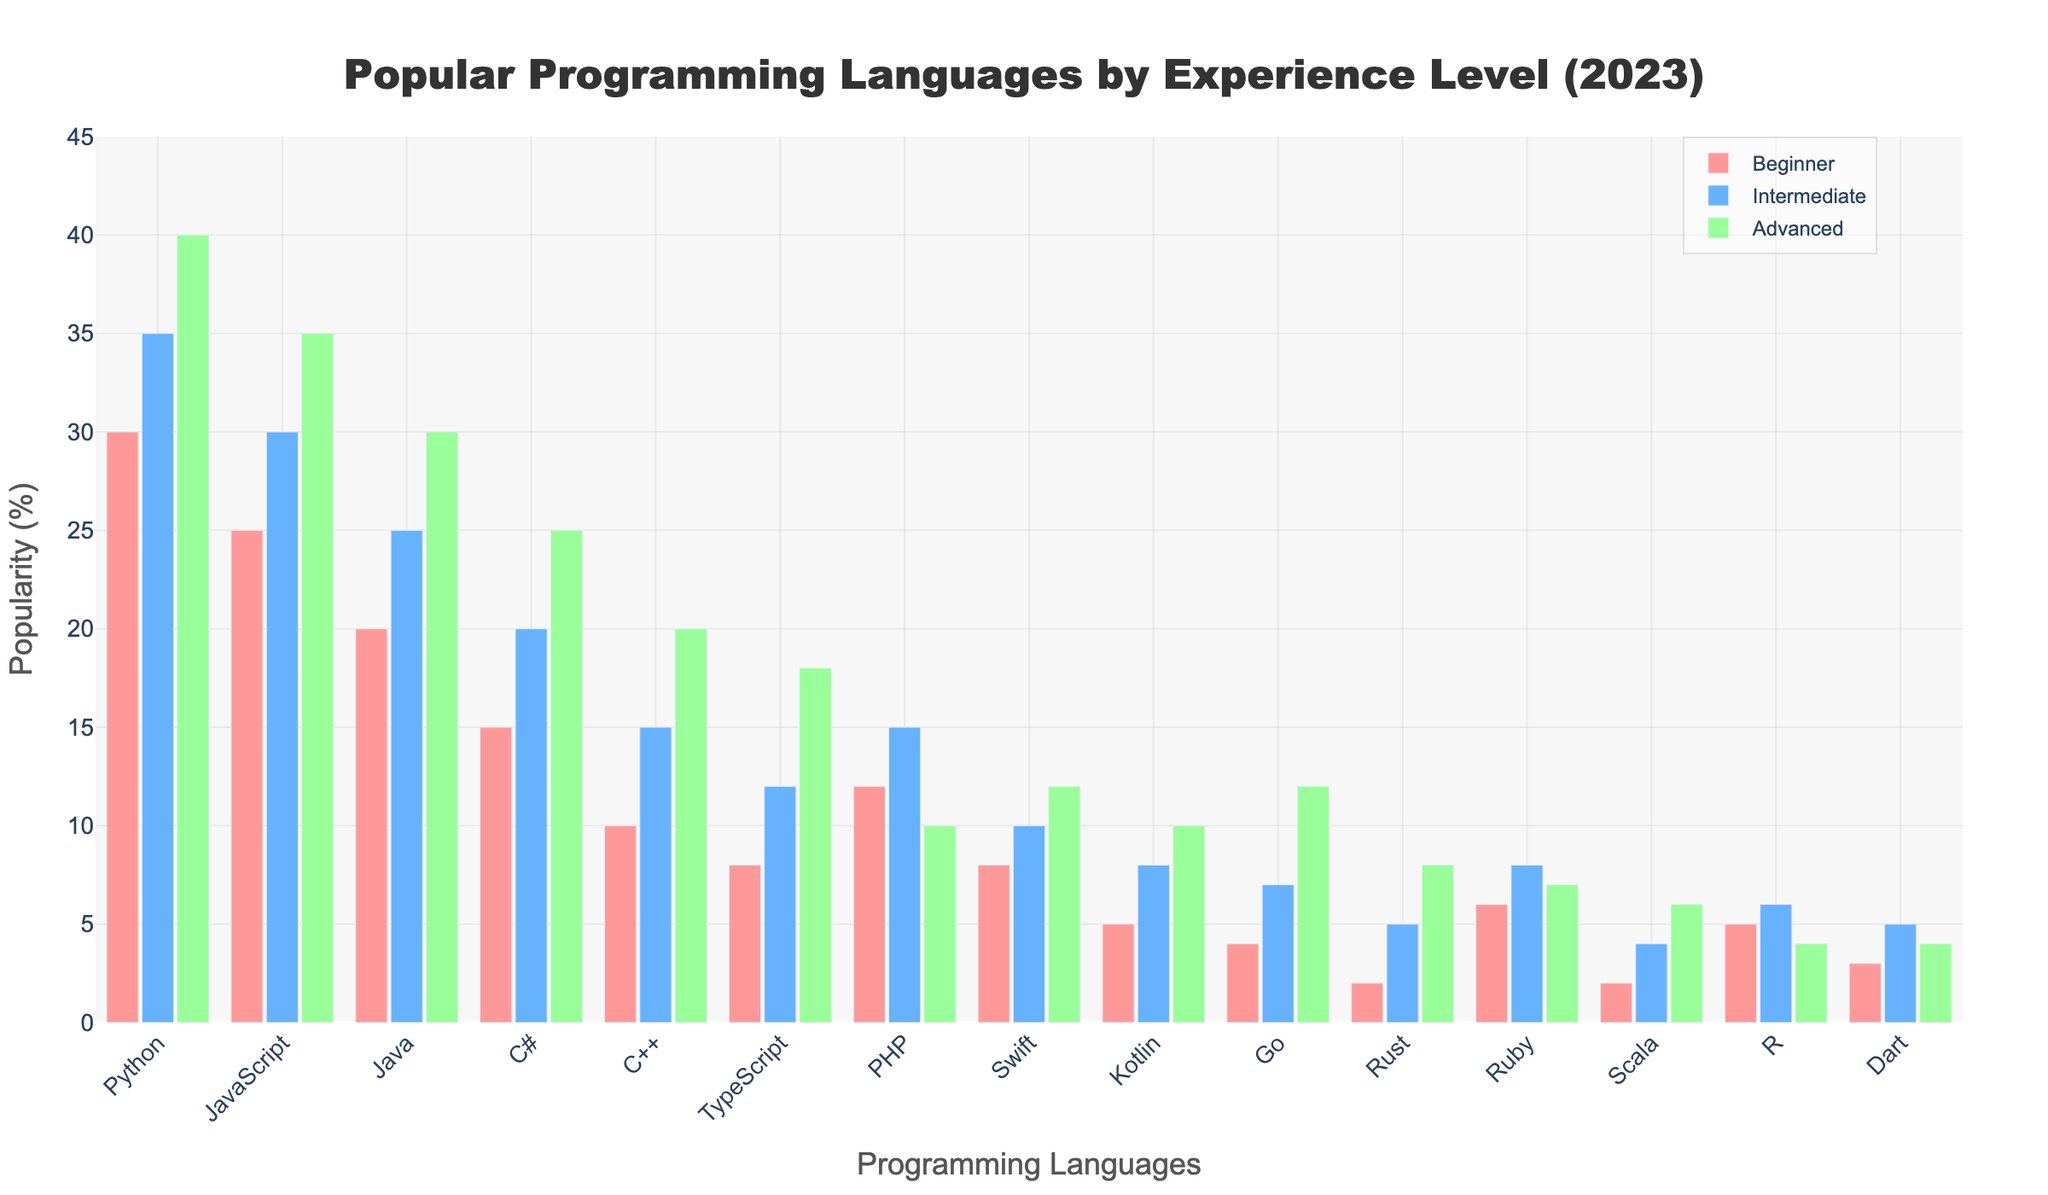What's the most popular programming language for beginners? Look at the heights of the bars corresponding to the "Beginner" level across all programming languages. The bar for Python is the tallest at this level.
Answer: Python Which experience level has the highest popularity in JavaScript? Compare the height of the bars for Beginner, Intermediate, and Advanced levels for JavaScript. The Advanced level has the tallest bar among the three.
Answer: Advanced What's the total popularity percentage for Go across all experience levels? Sum the percentages of Beginner, Intermediate, and Advanced for Go, which are 4, 7, and 12 respectively. 4 + 7 + 12 = 23.
Answer: 23% Which language has the least popularity among advanced developers? Compare the height of the bars for the "Advanced" category for all languages. The Rust and Scala bars are the shortest, but Rust is slightly lower.
Answer: Rust How much more popular is Python than Java for intermediate developers? Subtract the popularity percentage of Java in the Intermediate level from Python’s Intermediate level: 35 (Python) - 25 (Java) = 10.
Answer: 10% What's the average popularity of PHP across different experience levels? Calculate the average of the percentages for PHP: (12 + 15 + 10) / 3 = 37 / 3 ≈ 12.33.
Answer: 12.33% Which two languages have the same popularity among beginner developers? Compare the bars for the "Beginner" level. Both Swift and TypeScript have the same figure with 8%.
Answer: Swift and TypeScript What's the median value of the "Beginner" category percentages? Arrange the beginner percentages in ascending order: 2, 2, 3, 4, 5, 5, 6, 8, 8, 10, 12, 15, 20, 25, 30. The middle value (median) is at position 8, which is 8.
Answer: 8% Which language experienced the smallest increase when moving from beginner to advanced levels? Calculate the difference from beginner to advanced for each language and find the smallest difference: For PHP, the difference is 10 - 12 = -2 (decrease), other languages show a positive increase. Focus on positive increase only, PHP is out of consideration. R has the smallest positive increase: 4 - 5 = -1 (decrease considered positive as smallest increase in others are larger). Typically, the simplest increase is for TypeScript: 10.
Answer: TypeScript What's the combined popularity of C++ and R among advanced developers? Add the advanced level percentages for C++ and R: 20 + 4 = 24.
Answer: 24% 